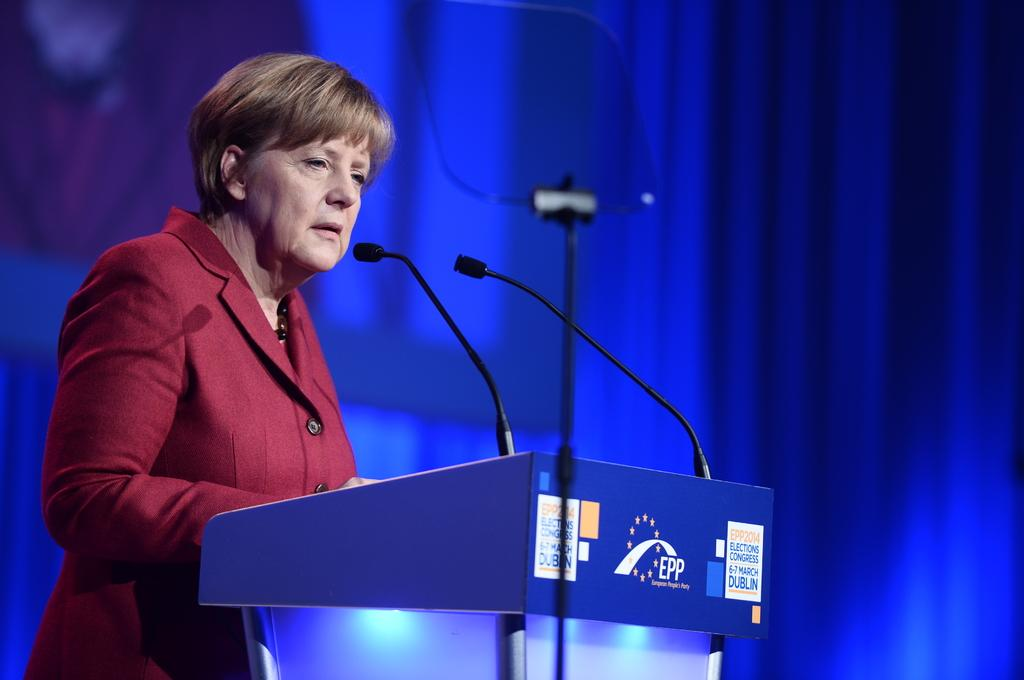Who is the main subject in the image? There is an old woman in the image. What is the old woman doing in the image? The old woman is standing near a podium and speaking into a microphone. What is the old woman wearing in the image? The old woman is wearing a dark red color coat. What is the color of the background in the image? There is a blue color background in the image. What type of watch is the old woman wearing in the image? There is no watch visible on the old woman in the image. Is there a chain attached to the microphone in the image? There is no chain visible in the image, only a microphone being held by the old woman. 